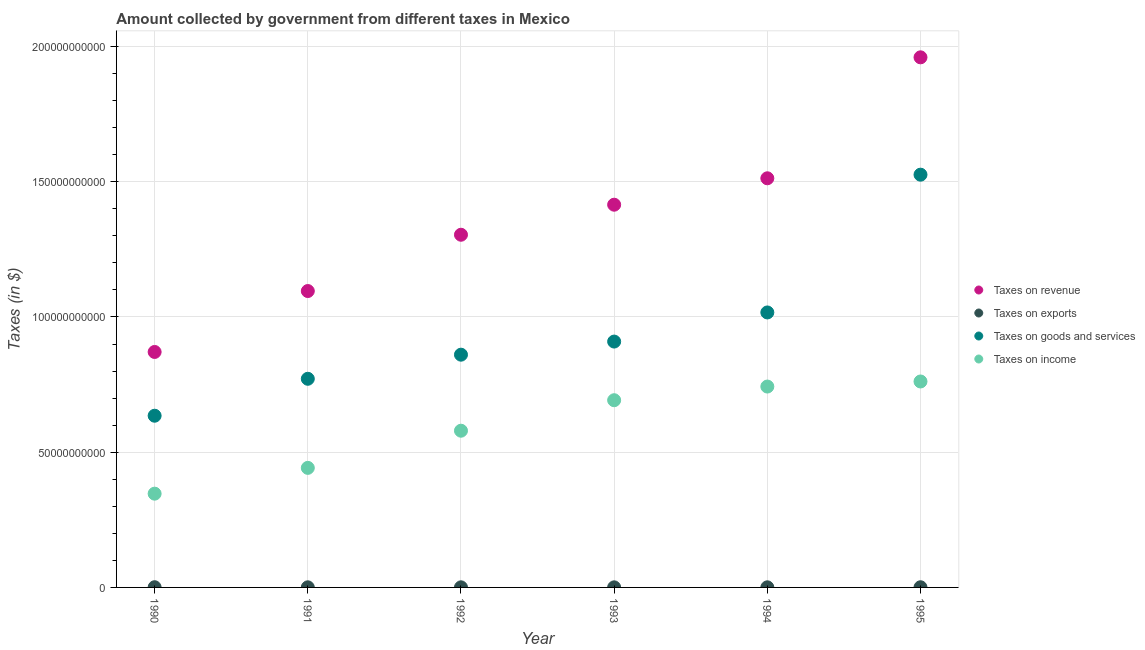What is the amount collected as tax on revenue in 1992?
Keep it short and to the point. 1.30e+11. Across all years, what is the maximum amount collected as tax on revenue?
Ensure brevity in your answer.  1.96e+11. Across all years, what is the minimum amount collected as tax on goods?
Make the answer very short. 6.35e+1. What is the total amount collected as tax on goods in the graph?
Ensure brevity in your answer.  5.72e+11. What is the difference between the amount collected as tax on goods in 1992 and that in 1993?
Offer a very short reply. -4.85e+09. What is the difference between the amount collected as tax on goods in 1994 and the amount collected as tax on revenue in 1990?
Your answer should be compact. 1.46e+1. What is the average amount collected as tax on goods per year?
Your answer should be compact. 9.53e+1. In the year 1994, what is the difference between the amount collected as tax on revenue and amount collected as tax on goods?
Give a very brief answer. 4.96e+1. In how many years, is the amount collected as tax on goods greater than 20000000000 $?
Keep it short and to the point. 6. What is the ratio of the amount collected as tax on income in 1993 to that in 1995?
Give a very brief answer. 0.91. What is the difference between the highest and the second highest amount collected as tax on revenue?
Provide a succinct answer. 4.47e+1. What is the difference between the highest and the lowest amount collected as tax on exports?
Provide a succinct answer. 4.40e+07. In how many years, is the amount collected as tax on income greater than the average amount collected as tax on income taken over all years?
Give a very brief answer. 3. Is the sum of the amount collected as tax on income in 1990 and 1992 greater than the maximum amount collected as tax on goods across all years?
Provide a succinct answer. No. Is it the case that in every year, the sum of the amount collected as tax on goods and amount collected as tax on exports is greater than the sum of amount collected as tax on revenue and amount collected as tax on income?
Offer a very short reply. Yes. Is it the case that in every year, the sum of the amount collected as tax on revenue and amount collected as tax on exports is greater than the amount collected as tax on goods?
Keep it short and to the point. Yes. Is the amount collected as tax on goods strictly less than the amount collected as tax on exports over the years?
Make the answer very short. No. How many dotlines are there?
Give a very brief answer. 4. How many years are there in the graph?
Make the answer very short. 6. What is the difference between two consecutive major ticks on the Y-axis?
Keep it short and to the point. 5.00e+1. Does the graph contain any zero values?
Ensure brevity in your answer.  No. Does the graph contain grids?
Keep it short and to the point. Yes. Where does the legend appear in the graph?
Offer a terse response. Center right. How many legend labels are there?
Your response must be concise. 4. How are the legend labels stacked?
Make the answer very short. Vertical. What is the title of the graph?
Keep it short and to the point. Amount collected by government from different taxes in Mexico. What is the label or title of the Y-axis?
Your answer should be very brief. Taxes (in $). What is the Taxes (in $) of Taxes on revenue in 1990?
Provide a succinct answer. 8.71e+1. What is the Taxes (in $) in Taxes on exports in 1990?
Your response must be concise. 7.50e+07. What is the Taxes (in $) of Taxes on goods and services in 1990?
Keep it short and to the point. 6.35e+1. What is the Taxes (in $) of Taxes on income in 1990?
Provide a succinct answer. 3.47e+1. What is the Taxes (in $) of Taxes on revenue in 1991?
Provide a succinct answer. 1.10e+11. What is the Taxes (in $) of Taxes on exports in 1991?
Provide a succinct answer. 4.10e+07. What is the Taxes (in $) in Taxes on goods and services in 1991?
Keep it short and to the point. 7.71e+1. What is the Taxes (in $) of Taxes on income in 1991?
Your answer should be compact. 4.42e+1. What is the Taxes (in $) of Taxes on revenue in 1992?
Ensure brevity in your answer.  1.30e+11. What is the Taxes (in $) of Taxes on exports in 1992?
Offer a very short reply. 3.80e+07. What is the Taxes (in $) of Taxes on goods and services in 1992?
Ensure brevity in your answer.  8.61e+1. What is the Taxes (in $) in Taxes on income in 1992?
Your answer should be very brief. 5.79e+1. What is the Taxes (in $) of Taxes on revenue in 1993?
Your answer should be very brief. 1.42e+11. What is the Taxes (in $) of Taxes on exports in 1993?
Ensure brevity in your answer.  3.10e+07. What is the Taxes (in $) in Taxes on goods and services in 1993?
Your answer should be compact. 9.09e+1. What is the Taxes (in $) of Taxes on income in 1993?
Keep it short and to the point. 6.92e+1. What is the Taxes (in $) in Taxes on revenue in 1994?
Provide a succinct answer. 1.51e+11. What is the Taxes (in $) of Taxes on exports in 1994?
Make the answer very short. 4.00e+07. What is the Taxes (in $) in Taxes on goods and services in 1994?
Make the answer very short. 1.02e+11. What is the Taxes (in $) in Taxes on income in 1994?
Your response must be concise. 7.43e+1. What is the Taxes (in $) in Taxes on revenue in 1995?
Provide a succinct answer. 1.96e+11. What is the Taxes (in $) in Taxes on exports in 1995?
Provide a succinct answer. 6.30e+07. What is the Taxes (in $) of Taxes on goods and services in 1995?
Offer a terse response. 1.53e+11. What is the Taxes (in $) of Taxes on income in 1995?
Ensure brevity in your answer.  7.61e+1. Across all years, what is the maximum Taxes (in $) in Taxes on revenue?
Your answer should be compact. 1.96e+11. Across all years, what is the maximum Taxes (in $) in Taxes on exports?
Provide a succinct answer. 7.50e+07. Across all years, what is the maximum Taxes (in $) in Taxes on goods and services?
Provide a succinct answer. 1.53e+11. Across all years, what is the maximum Taxes (in $) of Taxes on income?
Offer a terse response. 7.61e+1. Across all years, what is the minimum Taxes (in $) of Taxes on revenue?
Your answer should be very brief. 8.71e+1. Across all years, what is the minimum Taxes (in $) in Taxes on exports?
Ensure brevity in your answer.  3.10e+07. Across all years, what is the minimum Taxes (in $) of Taxes on goods and services?
Give a very brief answer. 6.35e+1. Across all years, what is the minimum Taxes (in $) in Taxes on income?
Ensure brevity in your answer.  3.47e+1. What is the total Taxes (in $) of Taxes on revenue in the graph?
Provide a succinct answer. 8.16e+11. What is the total Taxes (in $) of Taxes on exports in the graph?
Offer a terse response. 2.88e+08. What is the total Taxes (in $) in Taxes on goods and services in the graph?
Your response must be concise. 5.72e+11. What is the total Taxes (in $) in Taxes on income in the graph?
Ensure brevity in your answer.  3.56e+11. What is the difference between the Taxes (in $) of Taxes on revenue in 1990 and that in 1991?
Your answer should be compact. -2.25e+1. What is the difference between the Taxes (in $) of Taxes on exports in 1990 and that in 1991?
Offer a terse response. 3.40e+07. What is the difference between the Taxes (in $) in Taxes on goods and services in 1990 and that in 1991?
Your response must be concise. -1.37e+1. What is the difference between the Taxes (in $) of Taxes on income in 1990 and that in 1991?
Provide a short and direct response. -9.54e+09. What is the difference between the Taxes (in $) of Taxes on revenue in 1990 and that in 1992?
Offer a very short reply. -4.33e+1. What is the difference between the Taxes (in $) of Taxes on exports in 1990 and that in 1992?
Keep it short and to the point. 3.70e+07. What is the difference between the Taxes (in $) in Taxes on goods and services in 1990 and that in 1992?
Your answer should be compact. -2.26e+1. What is the difference between the Taxes (in $) of Taxes on income in 1990 and that in 1992?
Offer a very short reply. -2.33e+1. What is the difference between the Taxes (in $) of Taxes on revenue in 1990 and that in 1993?
Your answer should be compact. -5.44e+1. What is the difference between the Taxes (in $) in Taxes on exports in 1990 and that in 1993?
Offer a very short reply. 4.40e+07. What is the difference between the Taxes (in $) in Taxes on goods and services in 1990 and that in 1993?
Offer a very short reply. -2.74e+1. What is the difference between the Taxes (in $) of Taxes on income in 1990 and that in 1993?
Make the answer very short. -3.46e+1. What is the difference between the Taxes (in $) of Taxes on revenue in 1990 and that in 1994?
Keep it short and to the point. -6.42e+1. What is the difference between the Taxes (in $) in Taxes on exports in 1990 and that in 1994?
Offer a terse response. 3.50e+07. What is the difference between the Taxes (in $) of Taxes on goods and services in 1990 and that in 1994?
Provide a succinct answer. -3.82e+1. What is the difference between the Taxes (in $) of Taxes on income in 1990 and that in 1994?
Your response must be concise. -3.96e+1. What is the difference between the Taxes (in $) of Taxes on revenue in 1990 and that in 1995?
Offer a very short reply. -1.09e+11. What is the difference between the Taxes (in $) in Taxes on goods and services in 1990 and that in 1995?
Provide a short and direct response. -8.91e+1. What is the difference between the Taxes (in $) in Taxes on income in 1990 and that in 1995?
Your answer should be compact. -4.15e+1. What is the difference between the Taxes (in $) of Taxes on revenue in 1991 and that in 1992?
Your answer should be very brief. -2.08e+1. What is the difference between the Taxes (in $) of Taxes on exports in 1991 and that in 1992?
Your answer should be compact. 3.00e+06. What is the difference between the Taxes (in $) of Taxes on goods and services in 1991 and that in 1992?
Your answer should be compact. -8.92e+09. What is the difference between the Taxes (in $) of Taxes on income in 1991 and that in 1992?
Your answer should be very brief. -1.37e+1. What is the difference between the Taxes (in $) of Taxes on revenue in 1991 and that in 1993?
Provide a succinct answer. -3.19e+1. What is the difference between the Taxes (in $) in Taxes on goods and services in 1991 and that in 1993?
Provide a short and direct response. -1.38e+1. What is the difference between the Taxes (in $) of Taxes on income in 1991 and that in 1993?
Offer a terse response. -2.50e+1. What is the difference between the Taxes (in $) of Taxes on revenue in 1991 and that in 1994?
Your answer should be compact. -4.17e+1. What is the difference between the Taxes (in $) of Taxes on exports in 1991 and that in 1994?
Your response must be concise. 1.00e+06. What is the difference between the Taxes (in $) in Taxes on goods and services in 1991 and that in 1994?
Provide a short and direct response. -2.45e+1. What is the difference between the Taxes (in $) in Taxes on income in 1991 and that in 1994?
Your answer should be compact. -3.01e+1. What is the difference between the Taxes (in $) in Taxes on revenue in 1991 and that in 1995?
Make the answer very short. -8.64e+1. What is the difference between the Taxes (in $) in Taxes on exports in 1991 and that in 1995?
Provide a succinct answer. -2.20e+07. What is the difference between the Taxes (in $) in Taxes on goods and services in 1991 and that in 1995?
Your answer should be compact. -7.55e+1. What is the difference between the Taxes (in $) of Taxes on income in 1991 and that in 1995?
Your answer should be compact. -3.19e+1. What is the difference between the Taxes (in $) in Taxes on revenue in 1992 and that in 1993?
Ensure brevity in your answer.  -1.11e+1. What is the difference between the Taxes (in $) of Taxes on goods and services in 1992 and that in 1993?
Keep it short and to the point. -4.85e+09. What is the difference between the Taxes (in $) of Taxes on income in 1992 and that in 1993?
Keep it short and to the point. -1.13e+1. What is the difference between the Taxes (in $) in Taxes on revenue in 1992 and that in 1994?
Provide a succinct answer. -2.09e+1. What is the difference between the Taxes (in $) in Taxes on goods and services in 1992 and that in 1994?
Ensure brevity in your answer.  -1.56e+1. What is the difference between the Taxes (in $) of Taxes on income in 1992 and that in 1994?
Give a very brief answer. -1.63e+1. What is the difference between the Taxes (in $) in Taxes on revenue in 1992 and that in 1995?
Offer a terse response. -6.56e+1. What is the difference between the Taxes (in $) in Taxes on exports in 1992 and that in 1995?
Your answer should be very brief. -2.50e+07. What is the difference between the Taxes (in $) of Taxes on goods and services in 1992 and that in 1995?
Offer a very short reply. -6.66e+1. What is the difference between the Taxes (in $) in Taxes on income in 1992 and that in 1995?
Make the answer very short. -1.82e+1. What is the difference between the Taxes (in $) of Taxes on revenue in 1993 and that in 1994?
Make the answer very short. -9.77e+09. What is the difference between the Taxes (in $) in Taxes on exports in 1993 and that in 1994?
Make the answer very short. -9.00e+06. What is the difference between the Taxes (in $) of Taxes on goods and services in 1993 and that in 1994?
Ensure brevity in your answer.  -1.08e+1. What is the difference between the Taxes (in $) in Taxes on income in 1993 and that in 1994?
Keep it short and to the point. -5.05e+09. What is the difference between the Taxes (in $) of Taxes on revenue in 1993 and that in 1995?
Your answer should be very brief. -5.45e+1. What is the difference between the Taxes (in $) of Taxes on exports in 1993 and that in 1995?
Your response must be concise. -3.20e+07. What is the difference between the Taxes (in $) of Taxes on goods and services in 1993 and that in 1995?
Your answer should be very brief. -6.17e+1. What is the difference between the Taxes (in $) in Taxes on income in 1993 and that in 1995?
Provide a succinct answer. -6.93e+09. What is the difference between the Taxes (in $) of Taxes on revenue in 1994 and that in 1995?
Your answer should be very brief. -4.47e+1. What is the difference between the Taxes (in $) in Taxes on exports in 1994 and that in 1995?
Provide a short and direct response. -2.30e+07. What is the difference between the Taxes (in $) of Taxes on goods and services in 1994 and that in 1995?
Your response must be concise. -5.09e+1. What is the difference between the Taxes (in $) in Taxes on income in 1994 and that in 1995?
Provide a succinct answer. -1.87e+09. What is the difference between the Taxes (in $) in Taxes on revenue in 1990 and the Taxes (in $) in Taxes on exports in 1991?
Ensure brevity in your answer.  8.70e+1. What is the difference between the Taxes (in $) of Taxes on revenue in 1990 and the Taxes (in $) of Taxes on goods and services in 1991?
Your response must be concise. 9.92e+09. What is the difference between the Taxes (in $) of Taxes on revenue in 1990 and the Taxes (in $) of Taxes on income in 1991?
Provide a short and direct response. 4.29e+1. What is the difference between the Taxes (in $) of Taxes on exports in 1990 and the Taxes (in $) of Taxes on goods and services in 1991?
Provide a succinct answer. -7.71e+1. What is the difference between the Taxes (in $) of Taxes on exports in 1990 and the Taxes (in $) of Taxes on income in 1991?
Offer a very short reply. -4.41e+1. What is the difference between the Taxes (in $) in Taxes on goods and services in 1990 and the Taxes (in $) in Taxes on income in 1991?
Give a very brief answer. 1.93e+1. What is the difference between the Taxes (in $) of Taxes on revenue in 1990 and the Taxes (in $) of Taxes on exports in 1992?
Your answer should be compact. 8.70e+1. What is the difference between the Taxes (in $) of Taxes on revenue in 1990 and the Taxes (in $) of Taxes on goods and services in 1992?
Your answer should be very brief. 1.00e+09. What is the difference between the Taxes (in $) of Taxes on revenue in 1990 and the Taxes (in $) of Taxes on income in 1992?
Your response must be concise. 2.91e+1. What is the difference between the Taxes (in $) in Taxes on exports in 1990 and the Taxes (in $) in Taxes on goods and services in 1992?
Provide a succinct answer. -8.60e+1. What is the difference between the Taxes (in $) of Taxes on exports in 1990 and the Taxes (in $) of Taxes on income in 1992?
Your answer should be very brief. -5.79e+1. What is the difference between the Taxes (in $) of Taxes on goods and services in 1990 and the Taxes (in $) of Taxes on income in 1992?
Offer a very short reply. 5.54e+09. What is the difference between the Taxes (in $) in Taxes on revenue in 1990 and the Taxes (in $) in Taxes on exports in 1993?
Your answer should be very brief. 8.70e+1. What is the difference between the Taxes (in $) in Taxes on revenue in 1990 and the Taxes (in $) in Taxes on goods and services in 1993?
Provide a succinct answer. -3.84e+09. What is the difference between the Taxes (in $) of Taxes on revenue in 1990 and the Taxes (in $) of Taxes on income in 1993?
Offer a terse response. 1.78e+1. What is the difference between the Taxes (in $) in Taxes on exports in 1990 and the Taxes (in $) in Taxes on goods and services in 1993?
Keep it short and to the point. -9.08e+1. What is the difference between the Taxes (in $) in Taxes on exports in 1990 and the Taxes (in $) in Taxes on income in 1993?
Offer a terse response. -6.91e+1. What is the difference between the Taxes (in $) of Taxes on goods and services in 1990 and the Taxes (in $) of Taxes on income in 1993?
Your response must be concise. -5.74e+09. What is the difference between the Taxes (in $) of Taxes on revenue in 1990 and the Taxes (in $) of Taxes on exports in 1994?
Offer a very short reply. 8.70e+1. What is the difference between the Taxes (in $) of Taxes on revenue in 1990 and the Taxes (in $) of Taxes on goods and services in 1994?
Provide a short and direct response. -1.46e+1. What is the difference between the Taxes (in $) of Taxes on revenue in 1990 and the Taxes (in $) of Taxes on income in 1994?
Offer a terse response. 1.28e+1. What is the difference between the Taxes (in $) in Taxes on exports in 1990 and the Taxes (in $) in Taxes on goods and services in 1994?
Your response must be concise. -1.02e+11. What is the difference between the Taxes (in $) in Taxes on exports in 1990 and the Taxes (in $) in Taxes on income in 1994?
Make the answer very short. -7.42e+1. What is the difference between the Taxes (in $) in Taxes on goods and services in 1990 and the Taxes (in $) in Taxes on income in 1994?
Your response must be concise. -1.08e+1. What is the difference between the Taxes (in $) in Taxes on revenue in 1990 and the Taxes (in $) in Taxes on exports in 1995?
Give a very brief answer. 8.70e+1. What is the difference between the Taxes (in $) of Taxes on revenue in 1990 and the Taxes (in $) of Taxes on goods and services in 1995?
Provide a succinct answer. -6.56e+1. What is the difference between the Taxes (in $) in Taxes on revenue in 1990 and the Taxes (in $) in Taxes on income in 1995?
Your answer should be very brief. 1.09e+1. What is the difference between the Taxes (in $) of Taxes on exports in 1990 and the Taxes (in $) of Taxes on goods and services in 1995?
Give a very brief answer. -1.53e+11. What is the difference between the Taxes (in $) of Taxes on exports in 1990 and the Taxes (in $) of Taxes on income in 1995?
Provide a short and direct response. -7.61e+1. What is the difference between the Taxes (in $) in Taxes on goods and services in 1990 and the Taxes (in $) in Taxes on income in 1995?
Offer a terse response. -1.27e+1. What is the difference between the Taxes (in $) in Taxes on revenue in 1991 and the Taxes (in $) in Taxes on exports in 1992?
Your answer should be compact. 1.10e+11. What is the difference between the Taxes (in $) of Taxes on revenue in 1991 and the Taxes (in $) of Taxes on goods and services in 1992?
Your answer should be very brief. 2.35e+1. What is the difference between the Taxes (in $) of Taxes on revenue in 1991 and the Taxes (in $) of Taxes on income in 1992?
Give a very brief answer. 5.16e+1. What is the difference between the Taxes (in $) in Taxes on exports in 1991 and the Taxes (in $) in Taxes on goods and services in 1992?
Ensure brevity in your answer.  -8.60e+1. What is the difference between the Taxes (in $) of Taxes on exports in 1991 and the Taxes (in $) of Taxes on income in 1992?
Provide a succinct answer. -5.79e+1. What is the difference between the Taxes (in $) in Taxes on goods and services in 1991 and the Taxes (in $) in Taxes on income in 1992?
Provide a succinct answer. 1.92e+1. What is the difference between the Taxes (in $) in Taxes on revenue in 1991 and the Taxes (in $) in Taxes on exports in 1993?
Provide a succinct answer. 1.10e+11. What is the difference between the Taxes (in $) of Taxes on revenue in 1991 and the Taxes (in $) of Taxes on goods and services in 1993?
Make the answer very short. 1.87e+1. What is the difference between the Taxes (in $) of Taxes on revenue in 1991 and the Taxes (in $) of Taxes on income in 1993?
Offer a terse response. 4.04e+1. What is the difference between the Taxes (in $) in Taxes on exports in 1991 and the Taxes (in $) in Taxes on goods and services in 1993?
Provide a succinct answer. -9.09e+1. What is the difference between the Taxes (in $) of Taxes on exports in 1991 and the Taxes (in $) of Taxes on income in 1993?
Ensure brevity in your answer.  -6.92e+1. What is the difference between the Taxes (in $) of Taxes on goods and services in 1991 and the Taxes (in $) of Taxes on income in 1993?
Give a very brief answer. 7.92e+09. What is the difference between the Taxes (in $) in Taxes on revenue in 1991 and the Taxes (in $) in Taxes on exports in 1994?
Offer a very short reply. 1.10e+11. What is the difference between the Taxes (in $) in Taxes on revenue in 1991 and the Taxes (in $) in Taxes on goods and services in 1994?
Offer a terse response. 7.92e+09. What is the difference between the Taxes (in $) in Taxes on revenue in 1991 and the Taxes (in $) in Taxes on income in 1994?
Ensure brevity in your answer.  3.53e+1. What is the difference between the Taxes (in $) in Taxes on exports in 1991 and the Taxes (in $) in Taxes on goods and services in 1994?
Give a very brief answer. -1.02e+11. What is the difference between the Taxes (in $) in Taxes on exports in 1991 and the Taxes (in $) in Taxes on income in 1994?
Provide a short and direct response. -7.42e+1. What is the difference between the Taxes (in $) in Taxes on goods and services in 1991 and the Taxes (in $) in Taxes on income in 1994?
Your answer should be compact. 2.87e+09. What is the difference between the Taxes (in $) of Taxes on revenue in 1991 and the Taxes (in $) of Taxes on exports in 1995?
Your response must be concise. 1.10e+11. What is the difference between the Taxes (in $) of Taxes on revenue in 1991 and the Taxes (in $) of Taxes on goods and services in 1995?
Provide a short and direct response. -4.30e+1. What is the difference between the Taxes (in $) of Taxes on revenue in 1991 and the Taxes (in $) of Taxes on income in 1995?
Your response must be concise. 3.34e+1. What is the difference between the Taxes (in $) in Taxes on exports in 1991 and the Taxes (in $) in Taxes on goods and services in 1995?
Make the answer very short. -1.53e+11. What is the difference between the Taxes (in $) of Taxes on exports in 1991 and the Taxes (in $) of Taxes on income in 1995?
Provide a short and direct response. -7.61e+1. What is the difference between the Taxes (in $) of Taxes on goods and services in 1991 and the Taxes (in $) of Taxes on income in 1995?
Keep it short and to the point. 9.95e+08. What is the difference between the Taxes (in $) in Taxes on revenue in 1992 and the Taxes (in $) in Taxes on exports in 1993?
Offer a terse response. 1.30e+11. What is the difference between the Taxes (in $) in Taxes on revenue in 1992 and the Taxes (in $) in Taxes on goods and services in 1993?
Make the answer very short. 3.95e+1. What is the difference between the Taxes (in $) of Taxes on revenue in 1992 and the Taxes (in $) of Taxes on income in 1993?
Your answer should be very brief. 6.12e+1. What is the difference between the Taxes (in $) of Taxes on exports in 1992 and the Taxes (in $) of Taxes on goods and services in 1993?
Provide a succinct answer. -9.09e+1. What is the difference between the Taxes (in $) in Taxes on exports in 1992 and the Taxes (in $) in Taxes on income in 1993?
Offer a terse response. -6.92e+1. What is the difference between the Taxes (in $) of Taxes on goods and services in 1992 and the Taxes (in $) of Taxes on income in 1993?
Provide a short and direct response. 1.68e+1. What is the difference between the Taxes (in $) of Taxes on revenue in 1992 and the Taxes (in $) of Taxes on exports in 1994?
Your response must be concise. 1.30e+11. What is the difference between the Taxes (in $) in Taxes on revenue in 1992 and the Taxes (in $) in Taxes on goods and services in 1994?
Provide a short and direct response. 2.87e+1. What is the difference between the Taxes (in $) in Taxes on revenue in 1992 and the Taxes (in $) in Taxes on income in 1994?
Make the answer very short. 5.61e+1. What is the difference between the Taxes (in $) of Taxes on exports in 1992 and the Taxes (in $) of Taxes on goods and services in 1994?
Provide a succinct answer. -1.02e+11. What is the difference between the Taxes (in $) in Taxes on exports in 1992 and the Taxes (in $) in Taxes on income in 1994?
Ensure brevity in your answer.  -7.42e+1. What is the difference between the Taxes (in $) of Taxes on goods and services in 1992 and the Taxes (in $) of Taxes on income in 1994?
Offer a terse response. 1.18e+1. What is the difference between the Taxes (in $) in Taxes on revenue in 1992 and the Taxes (in $) in Taxes on exports in 1995?
Offer a very short reply. 1.30e+11. What is the difference between the Taxes (in $) in Taxes on revenue in 1992 and the Taxes (in $) in Taxes on goods and services in 1995?
Make the answer very short. -2.22e+1. What is the difference between the Taxes (in $) of Taxes on revenue in 1992 and the Taxes (in $) of Taxes on income in 1995?
Provide a succinct answer. 5.43e+1. What is the difference between the Taxes (in $) of Taxes on exports in 1992 and the Taxes (in $) of Taxes on goods and services in 1995?
Provide a succinct answer. -1.53e+11. What is the difference between the Taxes (in $) of Taxes on exports in 1992 and the Taxes (in $) of Taxes on income in 1995?
Your answer should be very brief. -7.61e+1. What is the difference between the Taxes (in $) of Taxes on goods and services in 1992 and the Taxes (in $) of Taxes on income in 1995?
Offer a very short reply. 9.91e+09. What is the difference between the Taxes (in $) in Taxes on revenue in 1993 and the Taxes (in $) in Taxes on exports in 1994?
Provide a short and direct response. 1.41e+11. What is the difference between the Taxes (in $) in Taxes on revenue in 1993 and the Taxes (in $) in Taxes on goods and services in 1994?
Your answer should be compact. 3.98e+1. What is the difference between the Taxes (in $) of Taxes on revenue in 1993 and the Taxes (in $) of Taxes on income in 1994?
Give a very brief answer. 6.72e+1. What is the difference between the Taxes (in $) in Taxes on exports in 1993 and the Taxes (in $) in Taxes on goods and services in 1994?
Make the answer very short. -1.02e+11. What is the difference between the Taxes (in $) of Taxes on exports in 1993 and the Taxes (in $) of Taxes on income in 1994?
Provide a short and direct response. -7.42e+1. What is the difference between the Taxes (in $) of Taxes on goods and services in 1993 and the Taxes (in $) of Taxes on income in 1994?
Your answer should be very brief. 1.66e+1. What is the difference between the Taxes (in $) in Taxes on revenue in 1993 and the Taxes (in $) in Taxes on exports in 1995?
Keep it short and to the point. 1.41e+11. What is the difference between the Taxes (in $) of Taxes on revenue in 1993 and the Taxes (in $) of Taxes on goods and services in 1995?
Provide a succinct answer. -1.11e+1. What is the difference between the Taxes (in $) of Taxes on revenue in 1993 and the Taxes (in $) of Taxes on income in 1995?
Provide a succinct answer. 6.54e+1. What is the difference between the Taxes (in $) of Taxes on exports in 1993 and the Taxes (in $) of Taxes on goods and services in 1995?
Keep it short and to the point. -1.53e+11. What is the difference between the Taxes (in $) of Taxes on exports in 1993 and the Taxes (in $) of Taxes on income in 1995?
Give a very brief answer. -7.61e+1. What is the difference between the Taxes (in $) of Taxes on goods and services in 1993 and the Taxes (in $) of Taxes on income in 1995?
Keep it short and to the point. 1.48e+1. What is the difference between the Taxes (in $) in Taxes on revenue in 1994 and the Taxes (in $) in Taxes on exports in 1995?
Offer a terse response. 1.51e+11. What is the difference between the Taxes (in $) in Taxes on revenue in 1994 and the Taxes (in $) in Taxes on goods and services in 1995?
Offer a very short reply. -1.34e+09. What is the difference between the Taxes (in $) of Taxes on revenue in 1994 and the Taxes (in $) of Taxes on income in 1995?
Provide a short and direct response. 7.51e+1. What is the difference between the Taxes (in $) in Taxes on exports in 1994 and the Taxes (in $) in Taxes on goods and services in 1995?
Provide a succinct answer. -1.53e+11. What is the difference between the Taxes (in $) of Taxes on exports in 1994 and the Taxes (in $) of Taxes on income in 1995?
Your response must be concise. -7.61e+1. What is the difference between the Taxes (in $) in Taxes on goods and services in 1994 and the Taxes (in $) in Taxes on income in 1995?
Ensure brevity in your answer.  2.55e+1. What is the average Taxes (in $) of Taxes on revenue per year?
Keep it short and to the point. 1.36e+11. What is the average Taxes (in $) of Taxes on exports per year?
Provide a short and direct response. 4.80e+07. What is the average Taxes (in $) of Taxes on goods and services per year?
Ensure brevity in your answer.  9.53e+1. What is the average Taxes (in $) in Taxes on income per year?
Give a very brief answer. 5.94e+1. In the year 1990, what is the difference between the Taxes (in $) in Taxes on revenue and Taxes (in $) in Taxes on exports?
Give a very brief answer. 8.70e+1. In the year 1990, what is the difference between the Taxes (in $) of Taxes on revenue and Taxes (in $) of Taxes on goods and services?
Provide a succinct answer. 2.36e+1. In the year 1990, what is the difference between the Taxes (in $) of Taxes on revenue and Taxes (in $) of Taxes on income?
Provide a succinct answer. 5.24e+1. In the year 1990, what is the difference between the Taxes (in $) in Taxes on exports and Taxes (in $) in Taxes on goods and services?
Ensure brevity in your answer.  -6.34e+1. In the year 1990, what is the difference between the Taxes (in $) of Taxes on exports and Taxes (in $) of Taxes on income?
Keep it short and to the point. -3.46e+1. In the year 1990, what is the difference between the Taxes (in $) of Taxes on goods and services and Taxes (in $) of Taxes on income?
Offer a very short reply. 2.88e+1. In the year 1991, what is the difference between the Taxes (in $) in Taxes on revenue and Taxes (in $) in Taxes on exports?
Keep it short and to the point. 1.10e+11. In the year 1991, what is the difference between the Taxes (in $) of Taxes on revenue and Taxes (in $) of Taxes on goods and services?
Your answer should be very brief. 3.24e+1. In the year 1991, what is the difference between the Taxes (in $) of Taxes on revenue and Taxes (in $) of Taxes on income?
Make the answer very short. 6.54e+1. In the year 1991, what is the difference between the Taxes (in $) in Taxes on exports and Taxes (in $) in Taxes on goods and services?
Ensure brevity in your answer.  -7.71e+1. In the year 1991, what is the difference between the Taxes (in $) of Taxes on exports and Taxes (in $) of Taxes on income?
Provide a succinct answer. -4.42e+1. In the year 1991, what is the difference between the Taxes (in $) in Taxes on goods and services and Taxes (in $) in Taxes on income?
Ensure brevity in your answer.  3.29e+1. In the year 1992, what is the difference between the Taxes (in $) in Taxes on revenue and Taxes (in $) in Taxes on exports?
Give a very brief answer. 1.30e+11. In the year 1992, what is the difference between the Taxes (in $) in Taxes on revenue and Taxes (in $) in Taxes on goods and services?
Provide a short and direct response. 4.43e+1. In the year 1992, what is the difference between the Taxes (in $) in Taxes on revenue and Taxes (in $) in Taxes on income?
Make the answer very short. 7.25e+1. In the year 1992, what is the difference between the Taxes (in $) in Taxes on exports and Taxes (in $) in Taxes on goods and services?
Offer a terse response. -8.60e+1. In the year 1992, what is the difference between the Taxes (in $) in Taxes on exports and Taxes (in $) in Taxes on income?
Offer a very short reply. -5.79e+1. In the year 1992, what is the difference between the Taxes (in $) in Taxes on goods and services and Taxes (in $) in Taxes on income?
Make the answer very short. 2.81e+1. In the year 1993, what is the difference between the Taxes (in $) in Taxes on revenue and Taxes (in $) in Taxes on exports?
Keep it short and to the point. 1.41e+11. In the year 1993, what is the difference between the Taxes (in $) of Taxes on revenue and Taxes (in $) of Taxes on goods and services?
Keep it short and to the point. 5.06e+1. In the year 1993, what is the difference between the Taxes (in $) in Taxes on revenue and Taxes (in $) in Taxes on income?
Make the answer very short. 7.23e+1. In the year 1993, what is the difference between the Taxes (in $) of Taxes on exports and Taxes (in $) of Taxes on goods and services?
Offer a very short reply. -9.09e+1. In the year 1993, what is the difference between the Taxes (in $) in Taxes on exports and Taxes (in $) in Taxes on income?
Give a very brief answer. -6.92e+1. In the year 1993, what is the difference between the Taxes (in $) of Taxes on goods and services and Taxes (in $) of Taxes on income?
Your response must be concise. 2.17e+1. In the year 1994, what is the difference between the Taxes (in $) in Taxes on revenue and Taxes (in $) in Taxes on exports?
Your response must be concise. 1.51e+11. In the year 1994, what is the difference between the Taxes (in $) of Taxes on revenue and Taxes (in $) of Taxes on goods and services?
Provide a succinct answer. 4.96e+1. In the year 1994, what is the difference between the Taxes (in $) of Taxes on revenue and Taxes (in $) of Taxes on income?
Your answer should be compact. 7.70e+1. In the year 1994, what is the difference between the Taxes (in $) in Taxes on exports and Taxes (in $) in Taxes on goods and services?
Give a very brief answer. -1.02e+11. In the year 1994, what is the difference between the Taxes (in $) in Taxes on exports and Taxes (in $) in Taxes on income?
Offer a terse response. -7.42e+1. In the year 1994, what is the difference between the Taxes (in $) of Taxes on goods and services and Taxes (in $) of Taxes on income?
Make the answer very short. 2.74e+1. In the year 1995, what is the difference between the Taxes (in $) in Taxes on revenue and Taxes (in $) in Taxes on exports?
Make the answer very short. 1.96e+11. In the year 1995, what is the difference between the Taxes (in $) in Taxes on revenue and Taxes (in $) in Taxes on goods and services?
Give a very brief answer. 4.34e+1. In the year 1995, what is the difference between the Taxes (in $) of Taxes on revenue and Taxes (in $) of Taxes on income?
Ensure brevity in your answer.  1.20e+11. In the year 1995, what is the difference between the Taxes (in $) of Taxes on exports and Taxes (in $) of Taxes on goods and services?
Your answer should be very brief. -1.53e+11. In the year 1995, what is the difference between the Taxes (in $) in Taxes on exports and Taxes (in $) in Taxes on income?
Your answer should be very brief. -7.61e+1. In the year 1995, what is the difference between the Taxes (in $) of Taxes on goods and services and Taxes (in $) of Taxes on income?
Give a very brief answer. 7.65e+1. What is the ratio of the Taxes (in $) in Taxes on revenue in 1990 to that in 1991?
Ensure brevity in your answer.  0.79. What is the ratio of the Taxes (in $) of Taxes on exports in 1990 to that in 1991?
Your answer should be very brief. 1.83. What is the ratio of the Taxes (in $) of Taxes on goods and services in 1990 to that in 1991?
Offer a very short reply. 0.82. What is the ratio of the Taxes (in $) in Taxes on income in 1990 to that in 1991?
Offer a terse response. 0.78. What is the ratio of the Taxes (in $) in Taxes on revenue in 1990 to that in 1992?
Offer a very short reply. 0.67. What is the ratio of the Taxes (in $) of Taxes on exports in 1990 to that in 1992?
Give a very brief answer. 1.97. What is the ratio of the Taxes (in $) in Taxes on goods and services in 1990 to that in 1992?
Your response must be concise. 0.74. What is the ratio of the Taxes (in $) of Taxes on income in 1990 to that in 1992?
Give a very brief answer. 0.6. What is the ratio of the Taxes (in $) in Taxes on revenue in 1990 to that in 1993?
Keep it short and to the point. 0.62. What is the ratio of the Taxes (in $) of Taxes on exports in 1990 to that in 1993?
Your answer should be compact. 2.42. What is the ratio of the Taxes (in $) in Taxes on goods and services in 1990 to that in 1993?
Your answer should be very brief. 0.7. What is the ratio of the Taxes (in $) in Taxes on income in 1990 to that in 1993?
Keep it short and to the point. 0.5. What is the ratio of the Taxes (in $) in Taxes on revenue in 1990 to that in 1994?
Provide a short and direct response. 0.58. What is the ratio of the Taxes (in $) in Taxes on exports in 1990 to that in 1994?
Provide a short and direct response. 1.88. What is the ratio of the Taxes (in $) in Taxes on goods and services in 1990 to that in 1994?
Your response must be concise. 0.62. What is the ratio of the Taxes (in $) in Taxes on income in 1990 to that in 1994?
Your answer should be very brief. 0.47. What is the ratio of the Taxes (in $) in Taxes on revenue in 1990 to that in 1995?
Offer a terse response. 0.44. What is the ratio of the Taxes (in $) in Taxes on exports in 1990 to that in 1995?
Give a very brief answer. 1.19. What is the ratio of the Taxes (in $) of Taxes on goods and services in 1990 to that in 1995?
Your response must be concise. 0.42. What is the ratio of the Taxes (in $) in Taxes on income in 1990 to that in 1995?
Ensure brevity in your answer.  0.46. What is the ratio of the Taxes (in $) of Taxes on revenue in 1991 to that in 1992?
Provide a short and direct response. 0.84. What is the ratio of the Taxes (in $) in Taxes on exports in 1991 to that in 1992?
Make the answer very short. 1.08. What is the ratio of the Taxes (in $) in Taxes on goods and services in 1991 to that in 1992?
Provide a succinct answer. 0.9. What is the ratio of the Taxes (in $) of Taxes on income in 1991 to that in 1992?
Your answer should be very brief. 0.76. What is the ratio of the Taxes (in $) in Taxes on revenue in 1991 to that in 1993?
Your response must be concise. 0.77. What is the ratio of the Taxes (in $) in Taxes on exports in 1991 to that in 1993?
Your response must be concise. 1.32. What is the ratio of the Taxes (in $) in Taxes on goods and services in 1991 to that in 1993?
Offer a very short reply. 0.85. What is the ratio of the Taxes (in $) of Taxes on income in 1991 to that in 1993?
Offer a very short reply. 0.64. What is the ratio of the Taxes (in $) of Taxes on revenue in 1991 to that in 1994?
Ensure brevity in your answer.  0.72. What is the ratio of the Taxes (in $) of Taxes on exports in 1991 to that in 1994?
Your response must be concise. 1.02. What is the ratio of the Taxes (in $) in Taxes on goods and services in 1991 to that in 1994?
Provide a succinct answer. 0.76. What is the ratio of the Taxes (in $) in Taxes on income in 1991 to that in 1994?
Keep it short and to the point. 0.6. What is the ratio of the Taxes (in $) in Taxes on revenue in 1991 to that in 1995?
Your response must be concise. 0.56. What is the ratio of the Taxes (in $) in Taxes on exports in 1991 to that in 1995?
Your response must be concise. 0.65. What is the ratio of the Taxes (in $) of Taxes on goods and services in 1991 to that in 1995?
Your answer should be very brief. 0.51. What is the ratio of the Taxes (in $) in Taxes on income in 1991 to that in 1995?
Make the answer very short. 0.58. What is the ratio of the Taxes (in $) in Taxes on revenue in 1992 to that in 1993?
Keep it short and to the point. 0.92. What is the ratio of the Taxes (in $) in Taxes on exports in 1992 to that in 1993?
Your answer should be very brief. 1.23. What is the ratio of the Taxes (in $) in Taxes on goods and services in 1992 to that in 1993?
Make the answer very short. 0.95. What is the ratio of the Taxes (in $) in Taxes on income in 1992 to that in 1993?
Ensure brevity in your answer.  0.84. What is the ratio of the Taxes (in $) of Taxes on revenue in 1992 to that in 1994?
Your response must be concise. 0.86. What is the ratio of the Taxes (in $) of Taxes on exports in 1992 to that in 1994?
Give a very brief answer. 0.95. What is the ratio of the Taxes (in $) of Taxes on goods and services in 1992 to that in 1994?
Provide a succinct answer. 0.85. What is the ratio of the Taxes (in $) in Taxes on income in 1992 to that in 1994?
Keep it short and to the point. 0.78. What is the ratio of the Taxes (in $) of Taxes on revenue in 1992 to that in 1995?
Your response must be concise. 0.67. What is the ratio of the Taxes (in $) in Taxes on exports in 1992 to that in 1995?
Keep it short and to the point. 0.6. What is the ratio of the Taxes (in $) of Taxes on goods and services in 1992 to that in 1995?
Make the answer very short. 0.56. What is the ratio of the Taxes (in $) of Taxes on income in 1992 to that in 1995?
Your response must be concise. 0.76. What is the ratio of the Taxes (in $) in Taxes on revenue in 1993 to that in 1994?
Provide a short and direct response. 0.94. What is the ratio of the Taxes (in $) in Taxes on exports in 1993 to that in 1994?
Your answer should be very brief. 0.78. What is the ratio of the Taxes (in $) of Taxes on goods and services in 1993 to that in 1994?
Keep it short and to the point. 0.89. What is the ratio of the Taxes (in $) in Taxes on income in 1993 to that in 1994?
Offer a very short reply. 0.93. What is the ratio of the Taxes (in $) in Taxes on revenue in 1993 to that in 1995?
Provide a succinct answer. 0.72. What is the ratio of the Taxes (in $) in Taxes on exports in 1993 to that in 1995?
Provide a succinct answer. 0.49. What is the ratio of the Taxes (in $) of Taxes on goods and services in 1993 to that in 1995?
Offer a very short reply. 0.6. What is the ratio of the Taxes (in $) of Taxes on income in 1993 to that in 1995?
Offer a terse response. 0.91. What is the ratio of the Taxes (in $) in Taxes on revenue in 1994 to that in 1995?
Your response must be concise. 0.77. What is the ratio of the Taxes (in $) of Taxes on exports in 1994 to that in 1995?
Your response must be concise. 0.63. What is the ratio of the Taxes (in $) in Taxes on goods and services in 1994 to that in 1995?
Your answer should be very brief. 0.67. What is the ratio of the Taxes (in $) in Taxes on income in 1994 to that in 1995?
Your answer should be very brief. 0.98. What is the difference between the highest and the second highest Taxes (in $) of Taxes on revenue?
Keep it short and to the point. 4.47e+1. What is the difference between the highest and the second highest Taxes (in $) in Taxes on goods and services?
Ensure brevity in your answer.  5.09e+1. What is the difference between the highest and the second highest Taxes (in $) in Taxes on income?
Your response must be concise. 1.87e+09. What is the difference between the highest and the lowest Taxes (in $) of Taxes on revenue?
Your answer should be very brief. 1.09e+11. What is the difference between the highest and the lowest Taxes (in $) of Taxes on exports?
Provide a short and direct response. 4.40e+07. What is the difference between the highest and the lowest Taxes (in $) in Taxes on goods and services?
Provide a short and direct response. 8.91e+1. What is the difference between the highest and the lowest Taxes (in $) in Taxes on income?
Provide a short and direct response. 4.15e+1. 